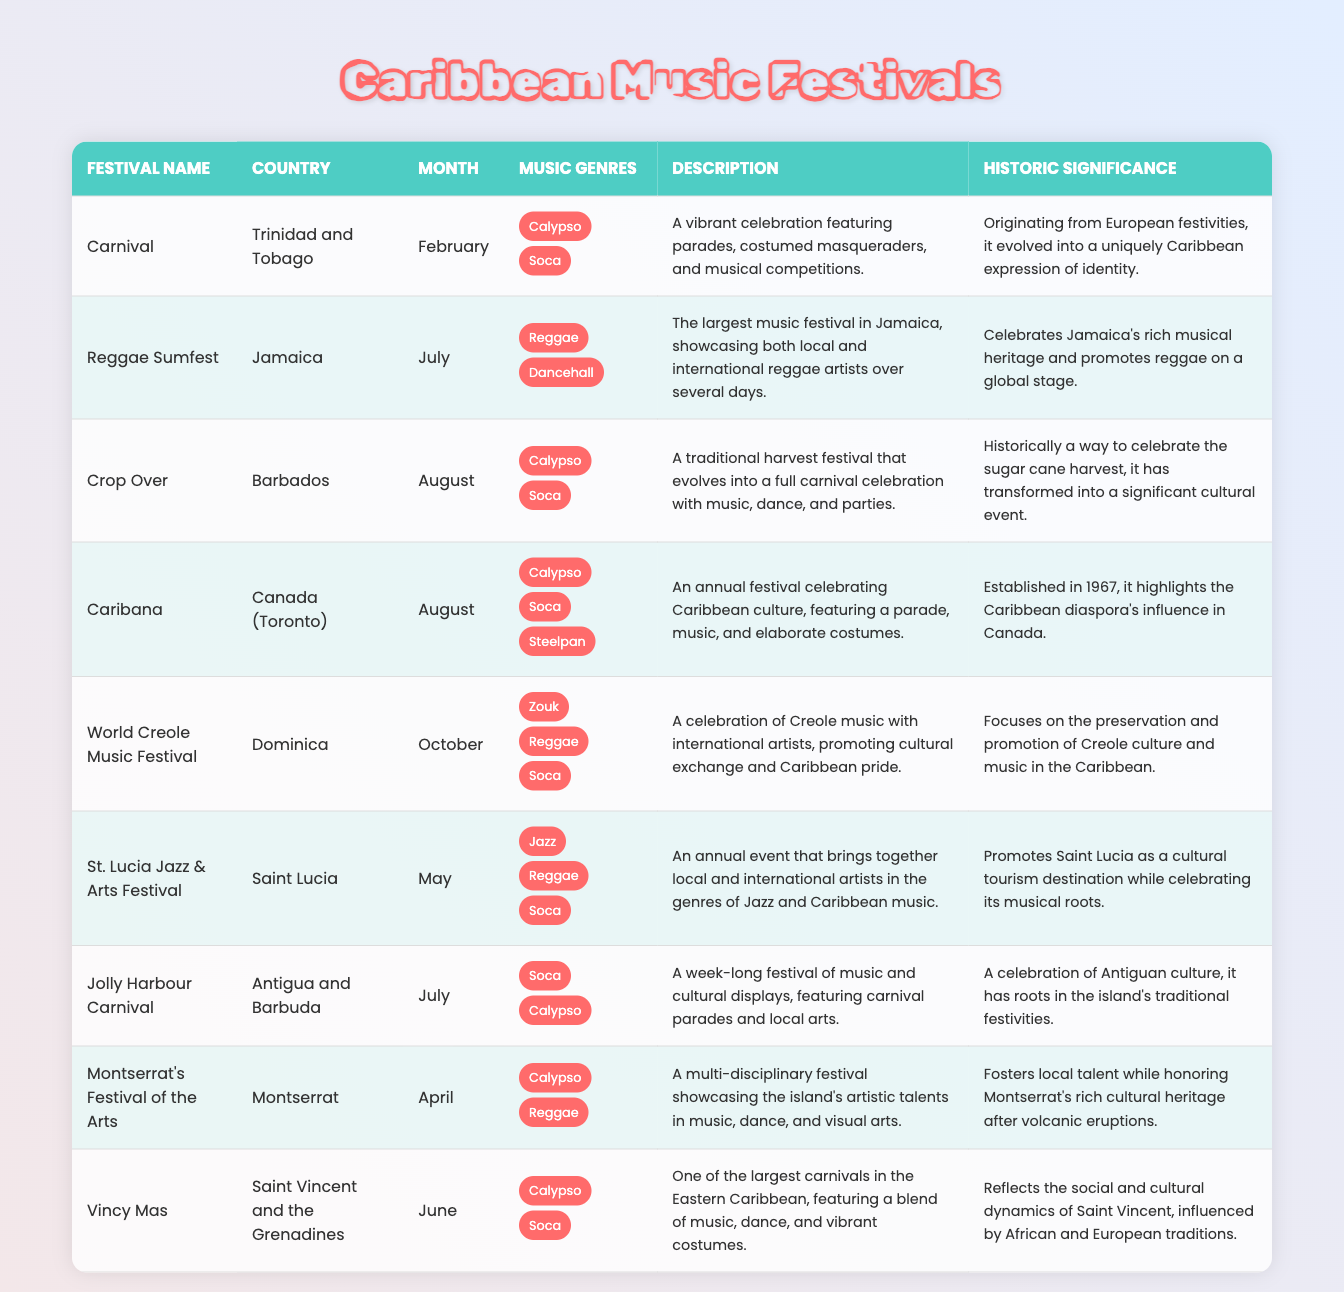What is the country that hosts the Carnival festival? According to the table, the Carnival festival is held in Trinidad and Tobago, as stated in the "country" column for that festival.
Answer: Trinidad and Tobago Which festival occurs in April? By examining the table, the festival listed in the month of April is Montserrat's Festival of the Arts, which can be found in the "month" column.
Answer: Montserrat's Festival of the Arts How many festivals celebrate the Calypso genre? The table shows that Calypso is mentioned under the music genres for Carnival, Crop Over, Jolly Harbour Carnival, Montserrat's Festival of the Arts, and Vincy Mas. Counting these festivals, we find there are five that celebrate Calypso.
Answer: 5 Is the World Creole Music Festival held in June? Checking the month for the World Creole Music Festival in the table reveals that it is actually held in October, not June. Therefore, the statement is false.
Answer: No What are the music genres celebrated during the St. Lucia Jazz & Arts Festival? The festival's row shows three music genres: Jazz, Reggae, and Soca. This information can be collected from the "music genres" column when looking specifically at the St. Lucia Jazz & Arts Festival.
Answer: Jazz, Reggae, Soca Which festival has the historic significance of celebrating a sugar cane harvest? The table clearly indicates that Crop Over historically celebrates the sugar cane harvest, as detailed in the "historic significance" column for this festival.
Answer: Crop Over How many festivals listed occur in the month of July? By reviewing the table for the month of July, we find that there are three festivals: Reggae Sumfest, Jolly Harbour Carnival, and it is also important to confirm that these entries are included within the rows corresponding to July. Therefore, there are three festivals.
Answer: 3 Does the Caribana festival feature Steelpan as one of its music genres? The table confirms that in the entry for Caribana, Steelpan is indeed listed as one of its music genres. So the statement is true.
Answer: Yes Which country has a festival that promotes Creole music? The World Creole Music Festival is hosted in Dominica, as specified in the country column corresponding to this festival. Thus, this festival promotes Creole music in Dominica.
Answer: Dominica 